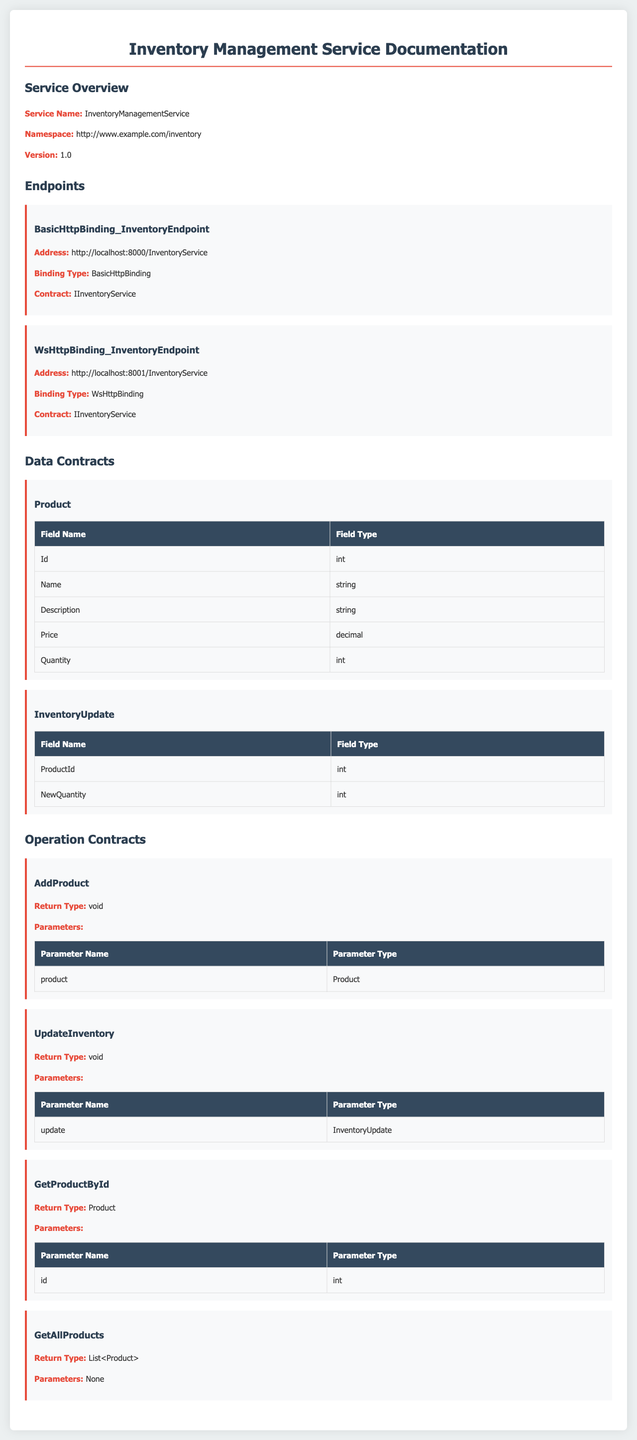What is the service name? The service name is stated in the service overview section of the document.
Answer: InventoryManagementService What is the version of the service? The version is specified in the service overview section.
Answer: 1.0 What binding type is used for the BasicHttpBinding inventory endpoint? The binding type is detailed in the endpoints section for each endpoint.
Answer: BasicHttpBinding How many data contracts are defined in the document? The document lists the data contracts in a section, including the names of each.
Answer: 2 What is the return type of the AddProduct operation? The return type is mentioned within the operation contracts section of the document.
Answer: void What is the parameter type for the GetProductById operation? The parameter type is described under the parameters heading for the specific operation in the contracts section.
Answer: int Which endpoint's address is http://localhost:8001/InventoryService? Each endpoint's address is indicated in the endpoints section, allowing us to specify connections.
Answer: WsHttpBinding_InventoryEndpoint How many parameters does the GetAllProducts operation have? This information can be found in the operation contracts section that lists the parameters for each operation.
Answer: None 